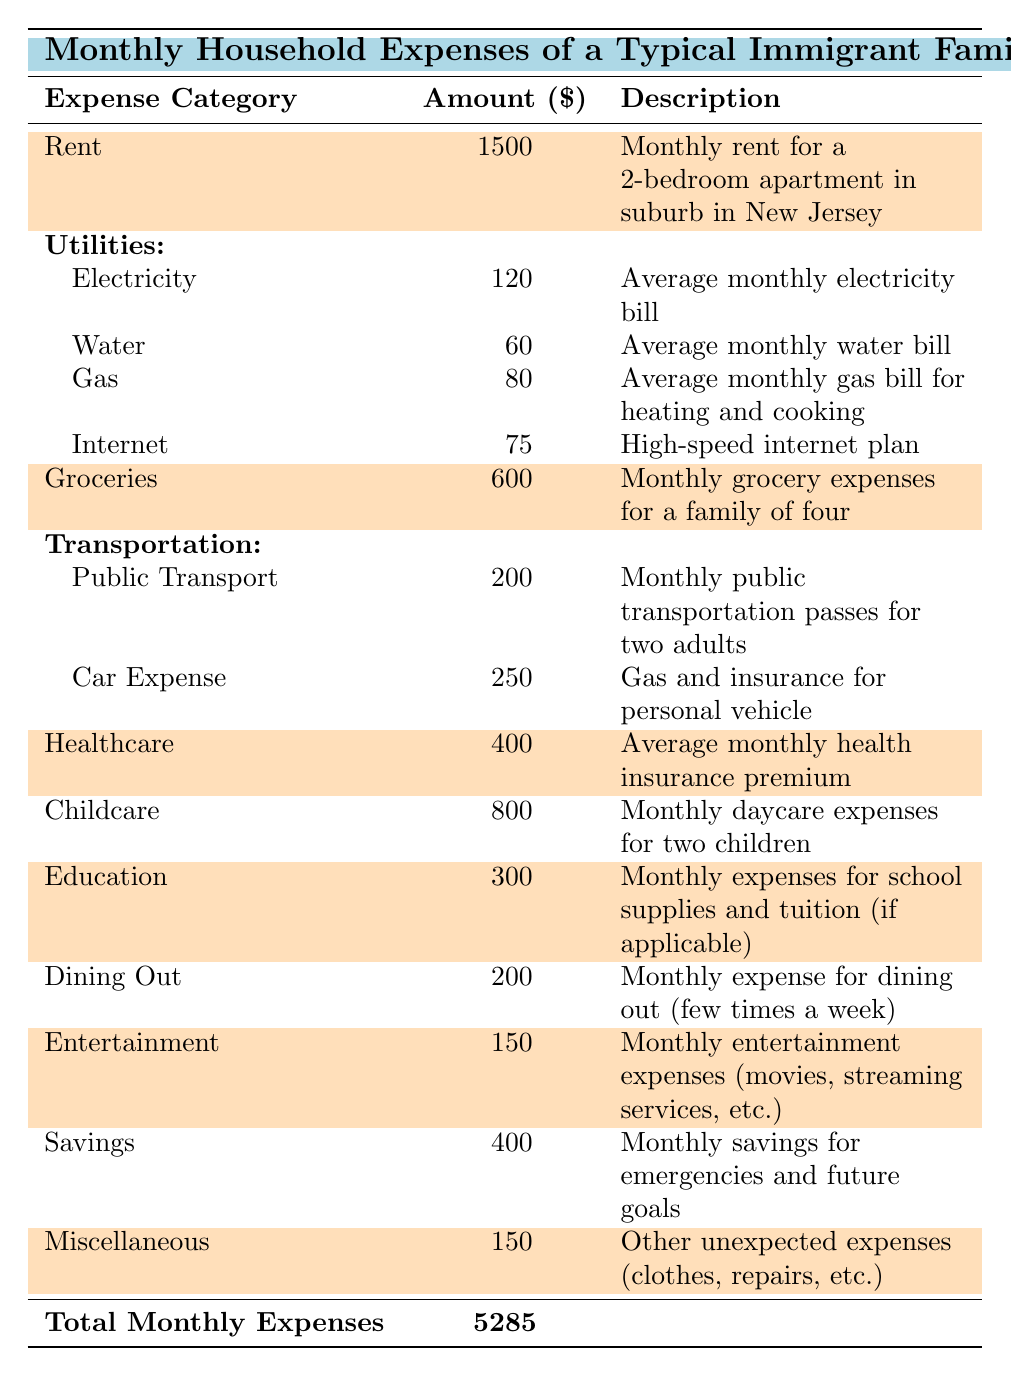What is the rent amount for the typical immigrant family? The rent category in the table states the amount is 1500 for a monthly rent for a 2-bedroom apartment.
Answer: 1500 What are the total utility expenses? To find the total utilities, we sum the individual amounts: 120 (Electricity) + 60 (Water) + 80 (Gas) + 75 (Internet) = 335.
Answer: 335 How much does the family spend monthly on groceries? The table indicates that the grocery expenses amount to 600 for the month.
Answer: 600 Is the average monthly health insurance premium more than 300? The table shows the health insurance premium is 400, which is indeed more than 300.
Answer: Yes What is the total monthly expense for child care and education combined? Combining the expenses, child care is 800 and education is 300, so 800 + 300 = 1100.
Answer: 1100 How much does the family spend on transportation? The transportation expenses are comprised of 200 for public transport and 250 for car expenses, totaling 200 + 250 = 450.
Answer: 450 What percentage of the total monthly expenses is allocated to savings? The total monthly expenses are 7595, and savings are 400. The percentage is calculated as (400/7595) * 100 ≈ 5.27%.
Answer: Approximately 5.27% If the family reduced dining out expenses by half, what would be the new total monthly expenses? Dining out is originally 200, halving it gives 100. The new total would be 7595 - 200 + 100 = 7495.
Answer: 7495 What is the combined cost of the family's entertainment and miscellaneous expenses? Entertainment costs 150 and miscellaneous is also 150, so the combined cost is 150 + 150 = 300.
Answer: 300 Is the total monthly expense greater than 7000? The total monthly expense is 7595, which is indeed greater than 7000.
Answer: Yes 